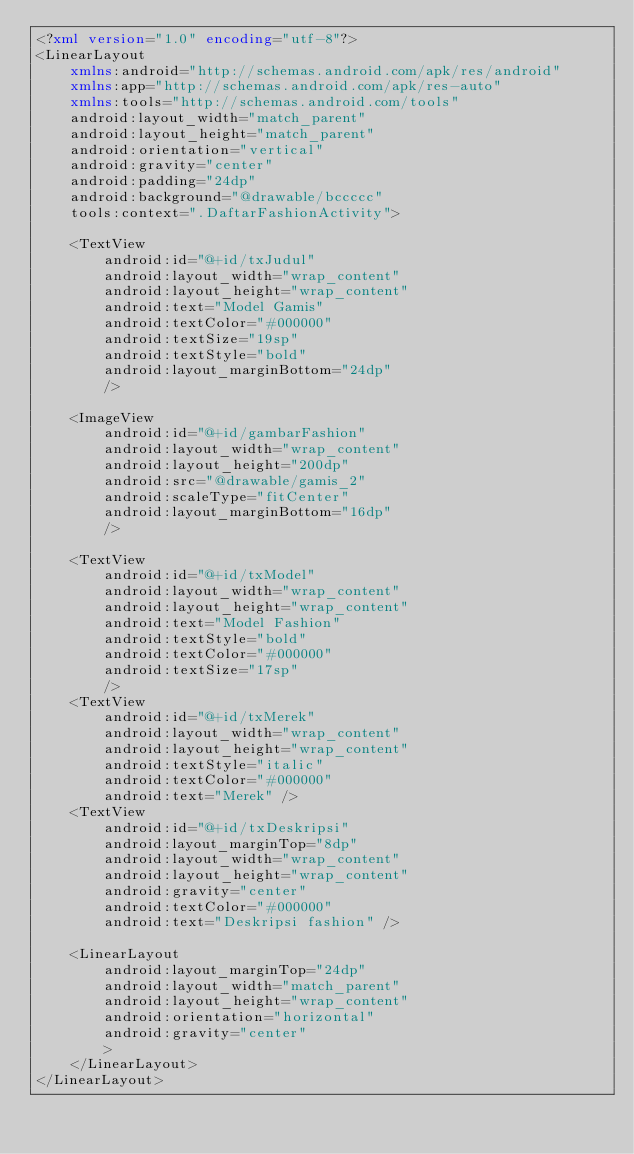Convert code to text. <code><loc_0><loc_0><loc_500><loc_500><_XML_><?xml version="1.0" encoding="utf-8"?>
<LinearLayout
    xmlns:android="http://schemas.android.com/apk/res/android"
    xmlns:app="http://schemas.android.com/apk/res-auto"
    xmlns:tools="http://schemas.android.com/tools"
    android:layout_width="match_parent"
    android:layout_height="match_parent"
    android:orientation="vertical"
    android:gravity="center"
    android:padding="24dp"
    android:background="@drawable/bccccc"
    tools:context=".DaftarFashionActivity">

    <TextView
        android:id="@+id/txJudul"
        android:layout_width="wrap_content"
        android:layout_height="wrap_content"
        android:text="Model Gamis"
        android:textColor="#000000"
        android:textSize="19sp"
        android:textStyle="bold"
        android:layout_marginBottom="24dp"
        />

    <ImageView
        android:id="@+id/gambarFashion"
        android:layout_width="wrap_content"
        android:layout_height="200dp"
        android:src="@drawable/gamis_2"
        android:scaleType="fitCenter"
        android:layout_marginBottom="16dp"
        />

    <TextView
        android:id="@+id/txModel"
        android:layout_width="wrap_content"
        android:layout_height="wrap_content"
        android:text="Model Fashion"
        android:textStyle="bold"
        android:textColor="#000000"
        android:textSize="17sp"
        />
    <TextView
        android:id="@+id/txMerek"
        android:layout_width="wrap_content"
        android:layout_height="wrap_content"
        android:textStyle="italic"
        android:textColor="#000000"
        android:text="Merek" />
    <TextView
        android:id="@+id/txDeskripsi"
        android:layout_marginTop="8dp"
        android:layout_width="wrap_content"
        android:layout_height="wrap_content"
        android:gravity="center"
        android:textColor="#000000"
        android:text="Deskripsi fashion" />

    <LinearLayout
        android:layout_marginTop="24dp"
        android:layout_width="match_parent"
        android:layout_height="wrap_content"
        android:orientation="horizontal"
        android:gravity="center"
        >
    </LinearLayout>
</LinearLayout></code> 